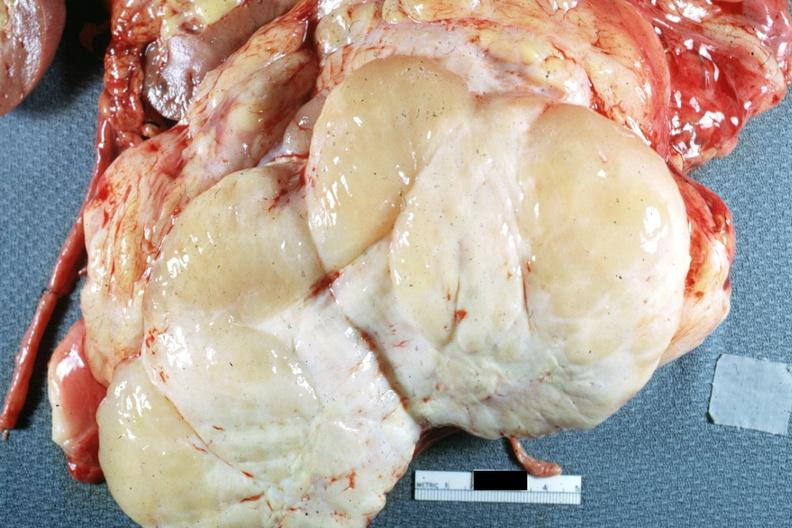what is present?
Answer the question using a single word or phrase. Peritoneum 